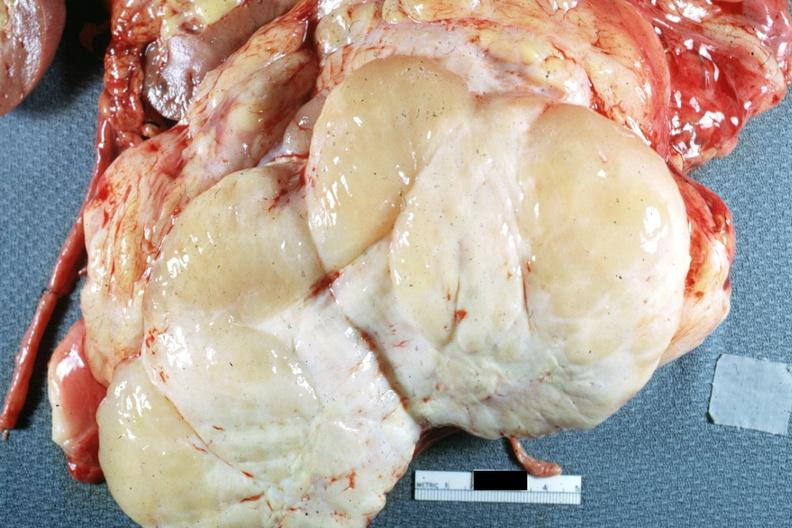what is present?
Answer the question using a single word or phrase. Peritoneum 